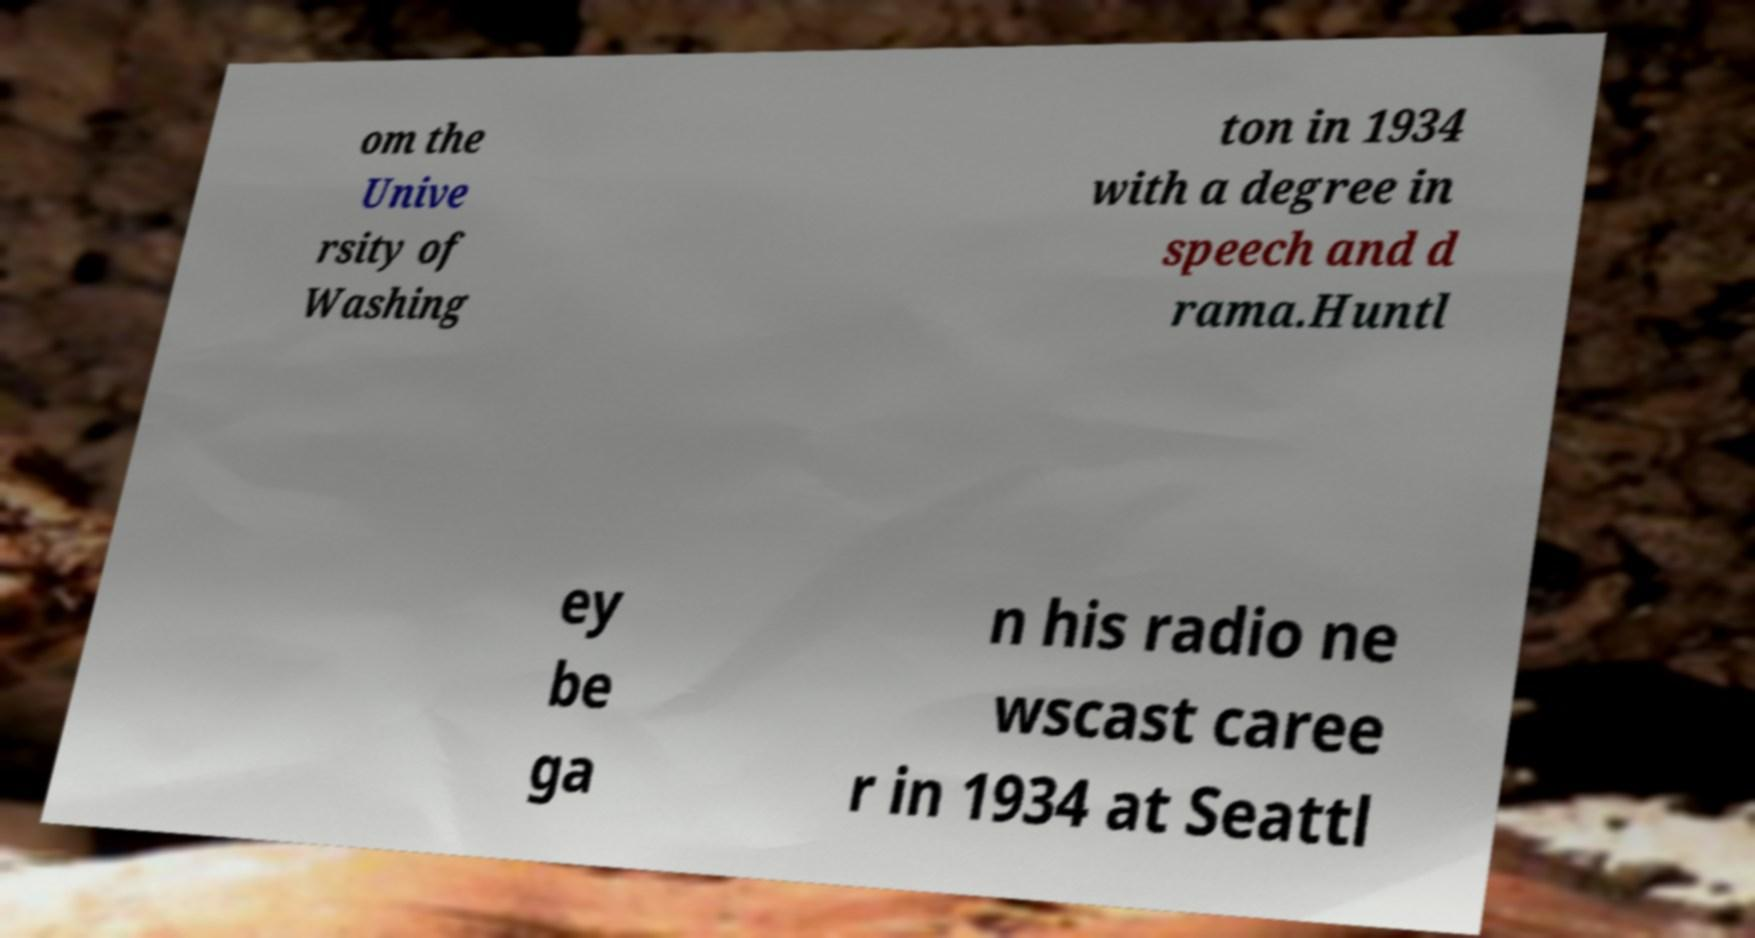Please identify and transcribe the text found in this image. om the Unive rsity of Washing ton in 1934 with a degree in speech and d rama.Huntl ey be ga n his radio ne wscast caree r in 1934 at Seattl 